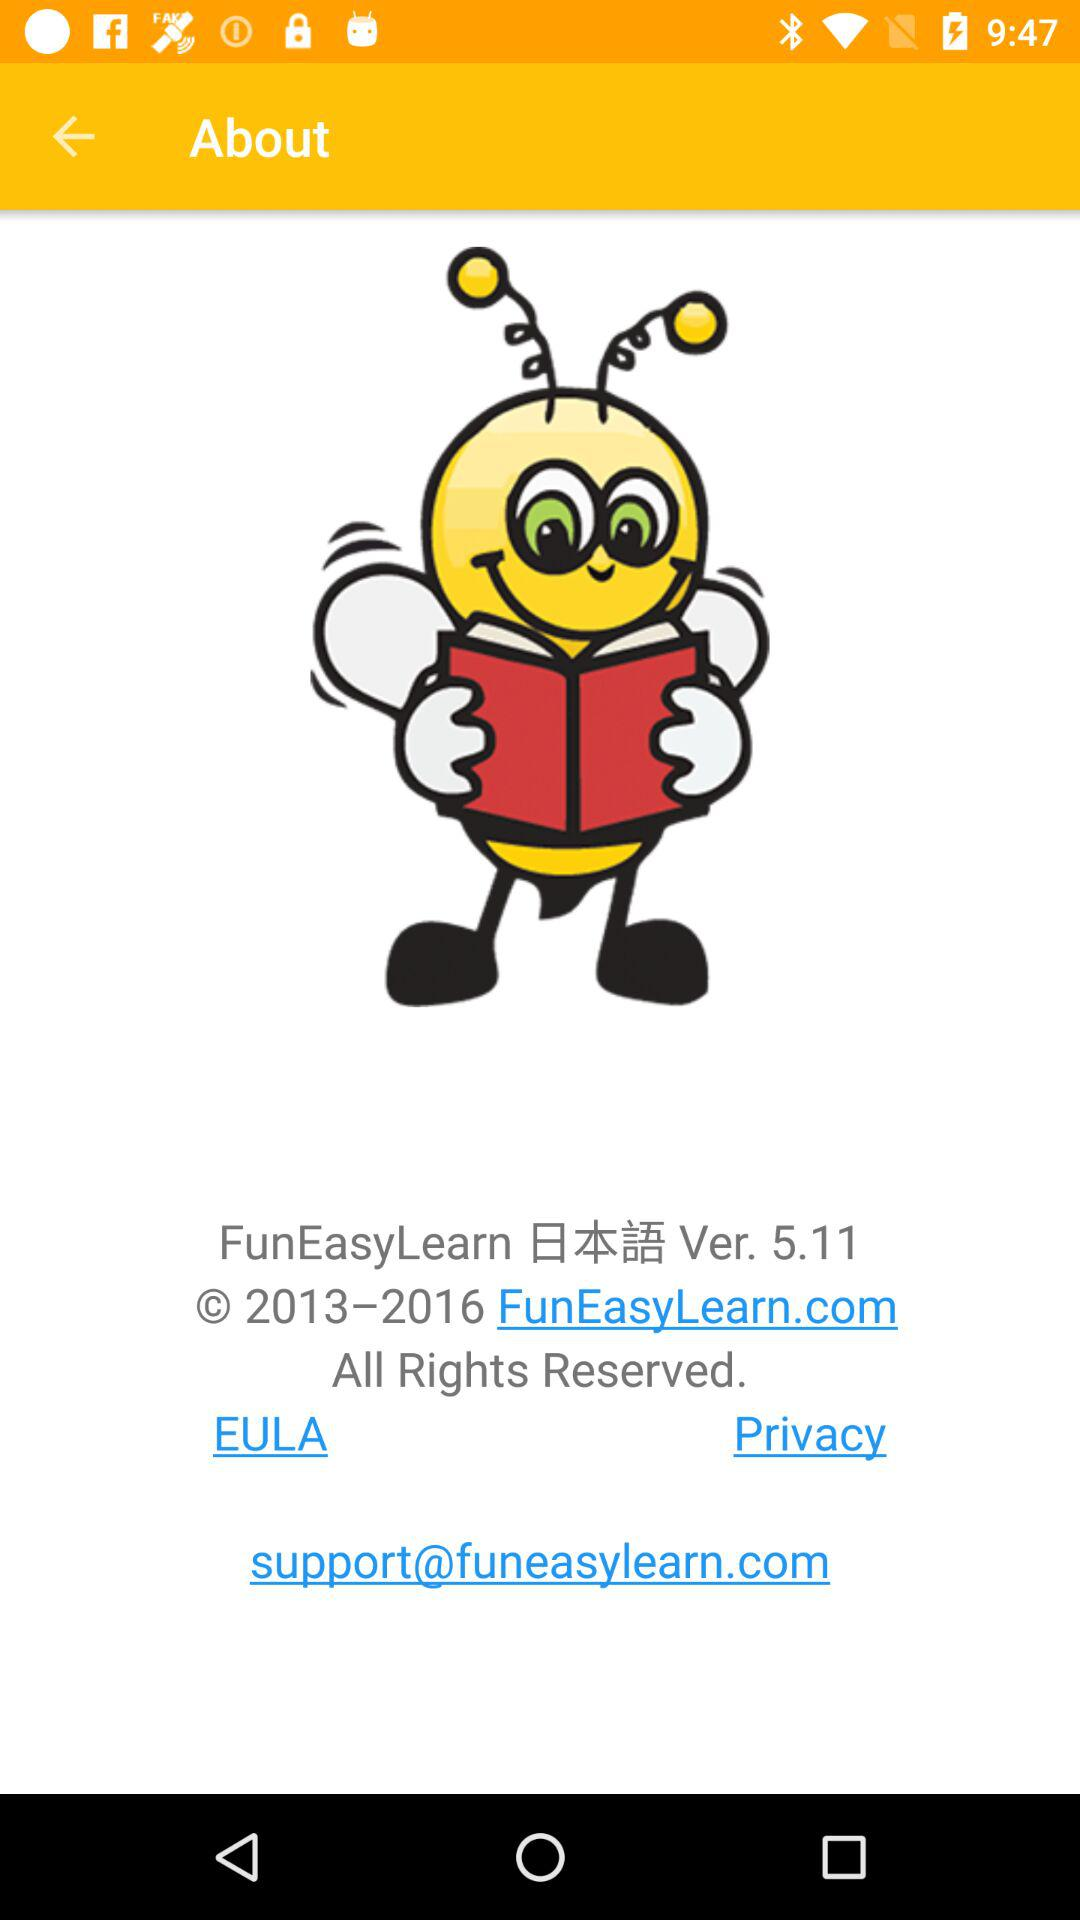What is the version number? The version number is 5.11. 